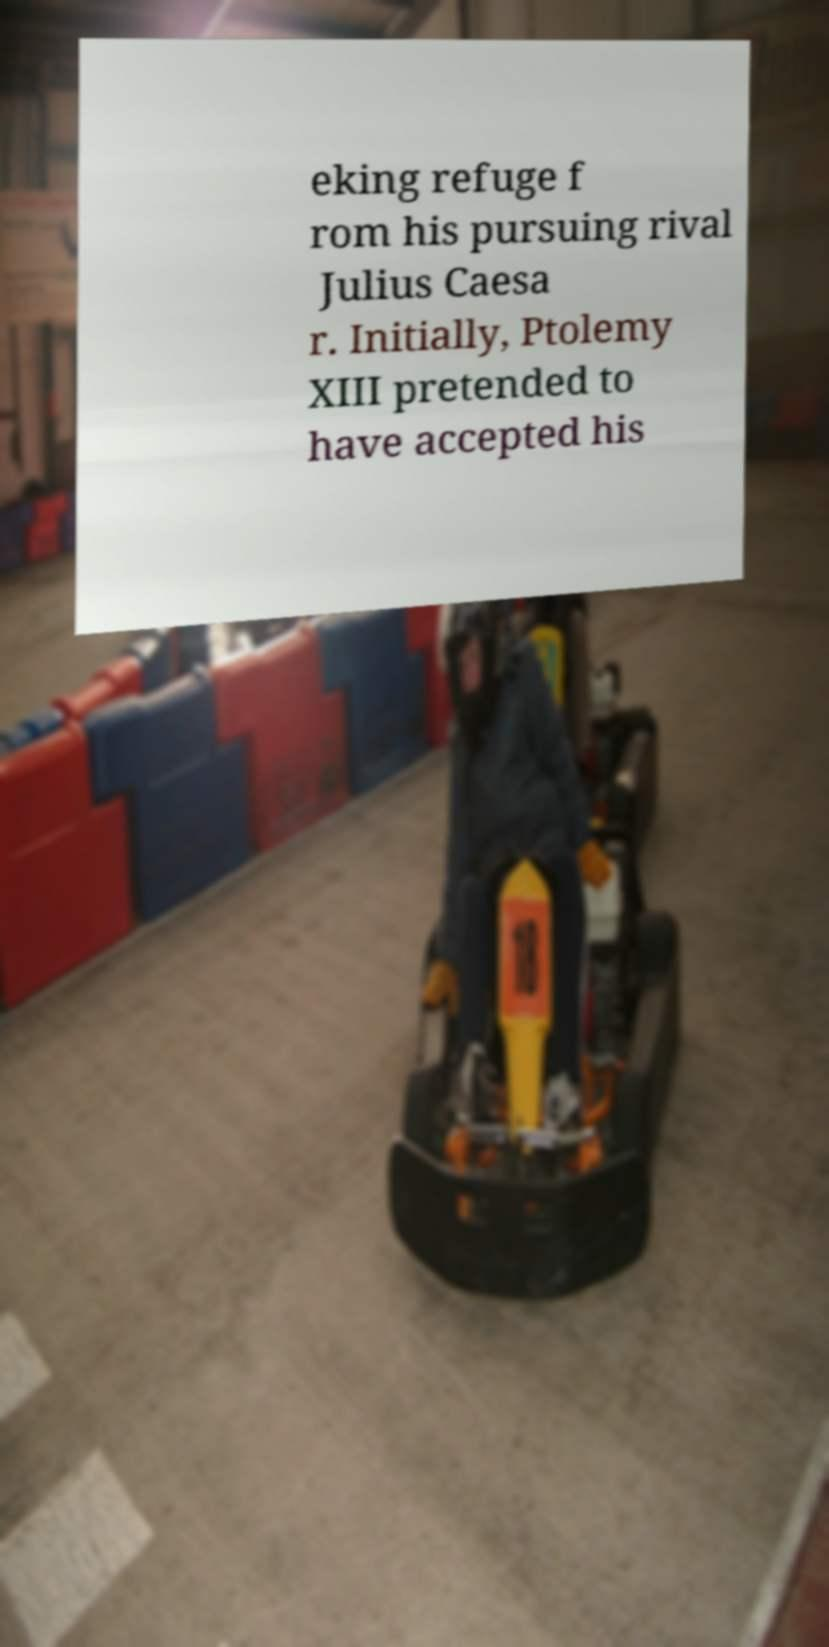Can you read and provide the text displayed in the image?This photo seems to have some interesting text. Can you extract and type it out for me? eking refuge f rom his pursuing rival Julius Caesa r. Initially, Ptolemy XIII pretended to have accepted his 